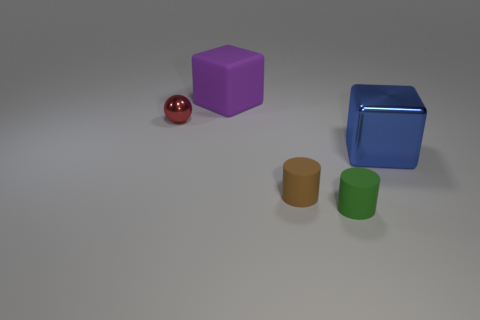Is there another big purple object of the same shape as the big metallic object?
Your answer should be very brief. Yes. What is the color of the object that is the same size as the blue metal cube?
Your answer should be very brief. Purple. Are there fewer blue metal blocks that are in front of the small green matte thing than blue metal blocks to the left of the tiny red sphere?
Give a very brief answer. No. Does the metal thing that is right of the purple matte cube have the same size as the green rubber cylinder?
Ensure brevity in your answer.  No. There is a small thing that is on the left side of the large purple thing; what is its shape?
Offer a terse response. Sphere. Are there more metallic cubes than metal objects?
Provide a succinct answer. No. Do the matte thing behind the red shiny object and the ball have the same color?
Your response must be concise. No. What number of objects are either objects that are on the left side of the big blue shiny cube or metal things in front of the red shiny sphere?
Keep it short and to the point. 5. How many objects are behind the blue shiny block and on the right side of the tiny metallic ball?
Your answer should be compact. 1. Is the red object made of the same material as the big purple block?
Your answer should be compact. No. 